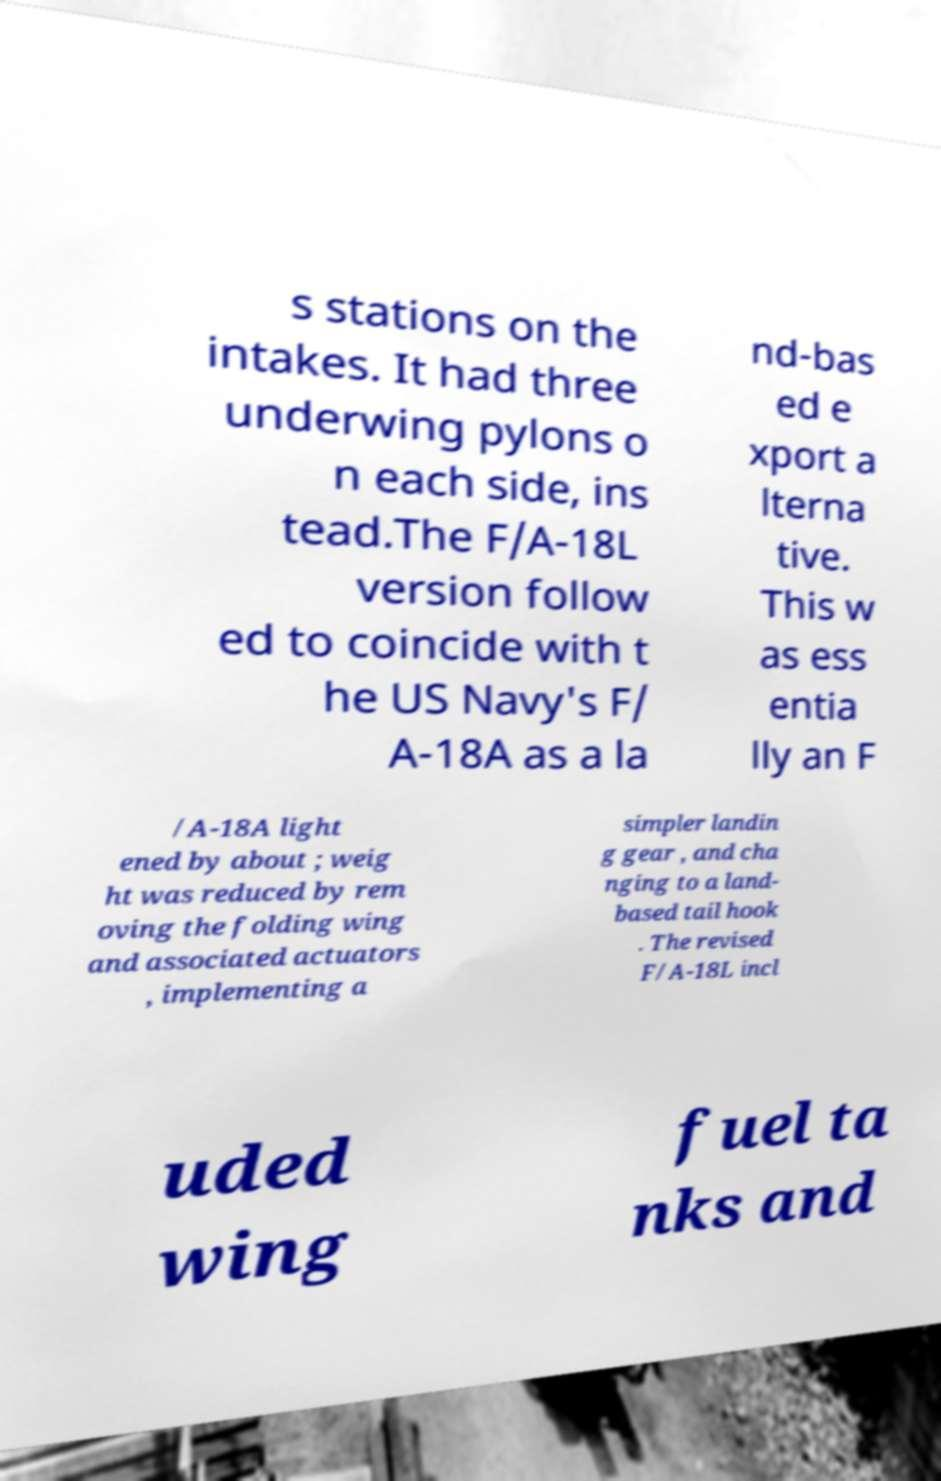Can you accurately transcribe the text from the provided image for me? s stations on the intakes. It had three underwing pylons o n each side, ins tead.The F/A-18L version follow ed to coincide with t he US Navy's F/ A-18A as a la nd-bas ed e xport a lterna tive. This w as ess entia lly an F /A-18A light ened by about ; weig ht was reduced by rem oving the folding wing and associated actuators , implementing a simpler landin g gear , and cha nging to a land- based tail hook . The revised F/A-18L incl uded wing fuel ta nks and 